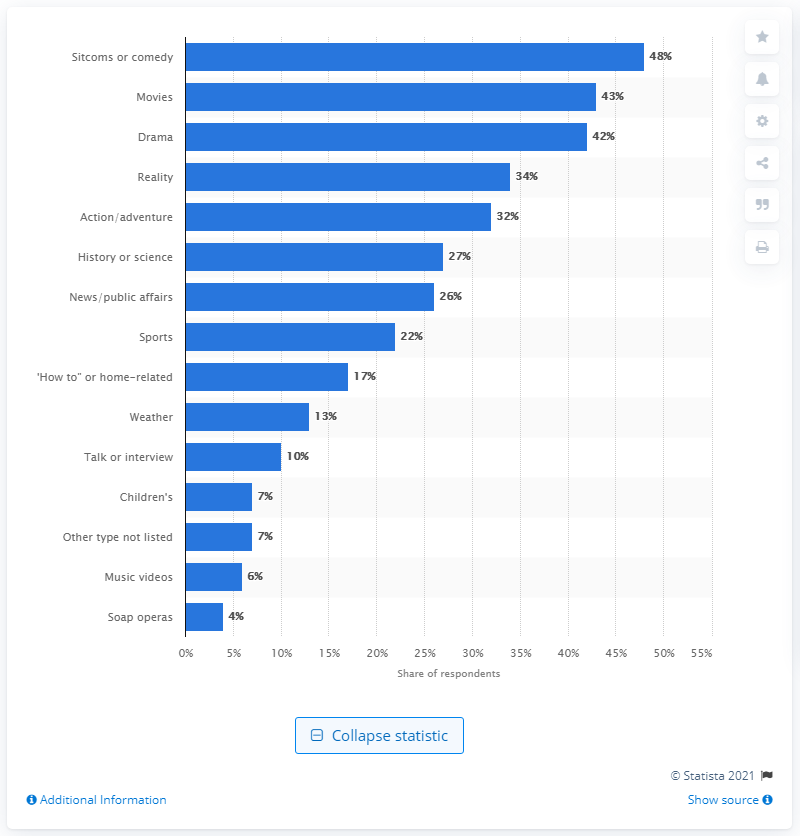Mention a couple of crucial points in this snapshot. The second most common genre on primetime TV programming is movies. 